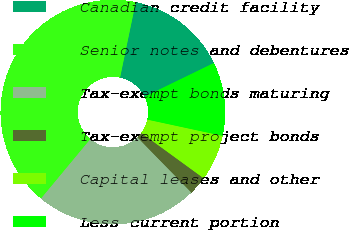<chart> <loc_0><loc_0><loc_500><loc_500><pie_chart><fcel>Canadian credit facility<fcel>Senior notes and debentures<fcel>Tax-exempt bonds maturing<fcel>Tax-exempt project bonds<fcel>Capital leases and other<fcel>Less current portion<nl><fcel>14.54%<fcel>42.24%<fcel>23.34%<fcel>2.67%<fcel>6.63%<fcel>10.58%<nl></chart> 